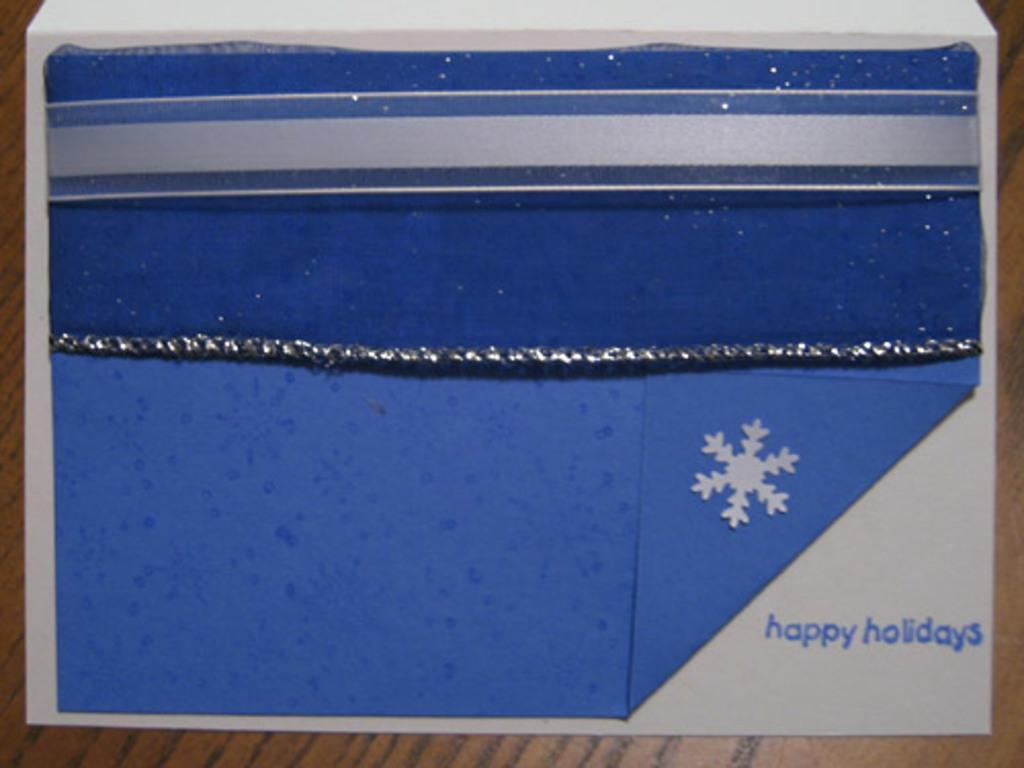<image>
Provide a brief description of the given image. a blue christmas card with a snow flake saying happy holidays 